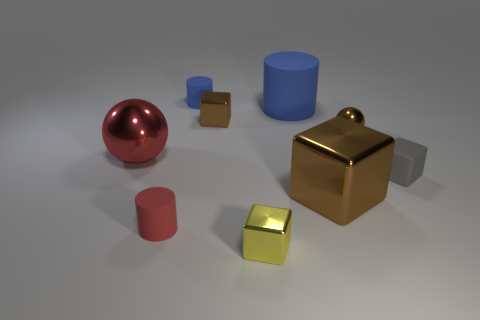Is the color of the small ball the same as the large metal block?
Your response must be concise. Yes. What size is the other matte cylinder that is the same color as the big matte cylinder?
Give a very brief answer. Small. What color is the matte thing that is the same size as the red metallic object?
Ensure brevity in your answer.  Blue. The brown metal object that is behind the tiny metal thing that is on the right side of the big blue matte cylinder behind the small shiny sphere is what shape?
Make the answer very short. Cube. What number of large brown metallic cubes are on the left side of the brown metallic cube in front of the gray rubber object?
Provide a short and direct response. 0. There is a tiny rubber object that is in front of the gray cube; is it the same shape as the small rubber thing that is behind the small gray matte cube?
Keep it short and to the point. Yes. There is a large red metal object; what number of matte objects are to the right of it?
Give a very brief answer. 4. Is the tiny thing that is behind the large matte object made of the same material as the red cylinder?
Provide a succinct answer. Yes. There is another object that is the same shape as the large red metal thing; what color is it?
Provide a short and direct response. Brown. What is the shape of the gray matte thing?
Offer a terse response. Cube. 